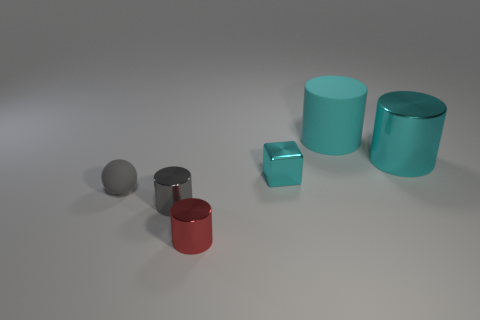What is the size of the cyan cylinder that is the same material as the red cylinder?
Your answer should be very brief. Large. There is a small gray matte thing behind the cylinder that is in front of the gray metallic object; what is its shape?
Provide a short and direct response. Sphere. How many red things are big matte cylinders or matte objects?
Make the answer very short. 0. There is a rubber thing behind the cyan object that is right of the cyan rubber thing; are there any large cyan things that are to the right of it?
Offer a very short reply. Yes. What is the shape of the other large thing that is the same color as the big metal object?
Make the answer very short. Cylinder. What number of small objects are either cyan metal cubes or shiny cylinders?
Offer a terse response. 3. There is a big cyan object that is on the left side of the large cyan metal object; is its shape the same as the tiny rubber thing?
Your answer should be compact. No. Are there fewer metallic cylinders than things?
Offer a very short reply. Yes. Is there anything else of the same color as the tiny rubber sphere?
Ensure brevity in your answer.  Yes. What shape is the rubber thing on the left side of the big cyan matte cylinder?
Ensure brevity in your answer.  Sphere. 